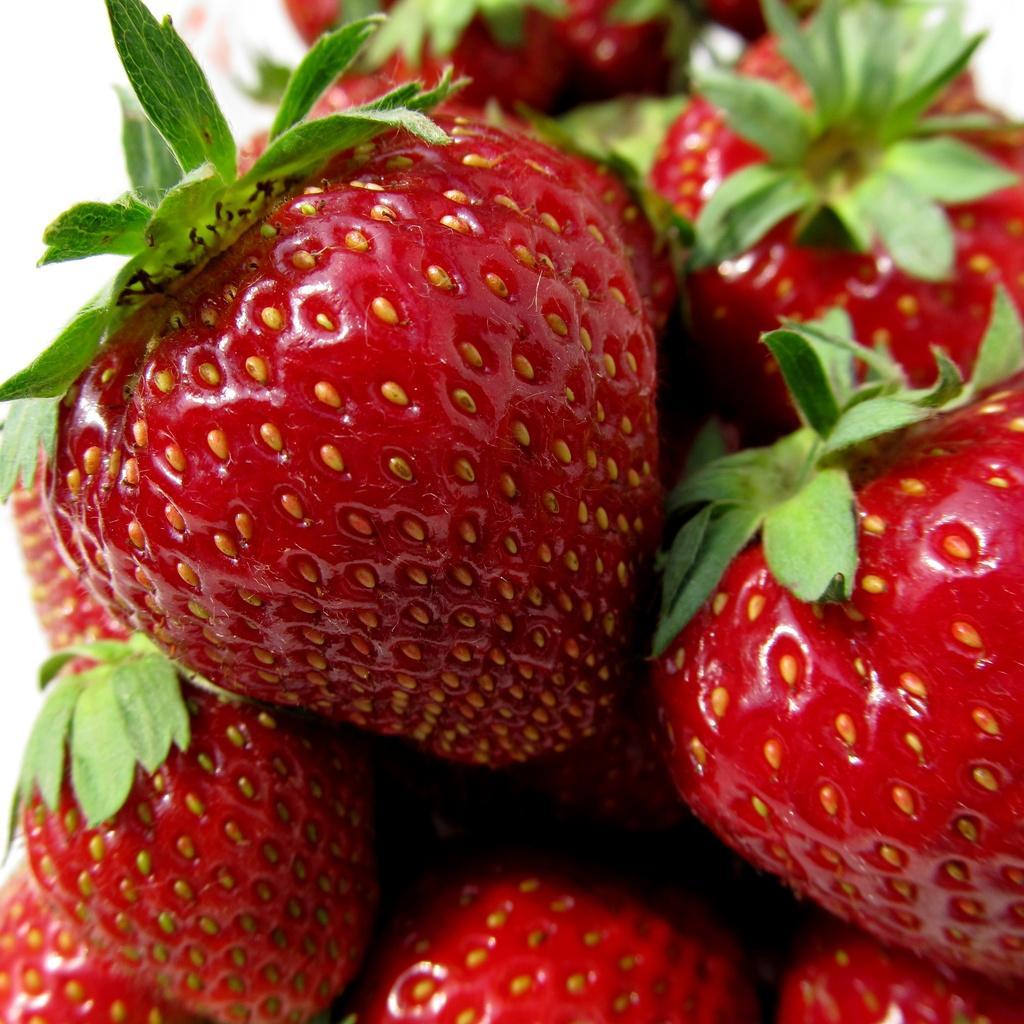How would you summarize this image in a sentence or two? In this image, we can see some strawberries. 